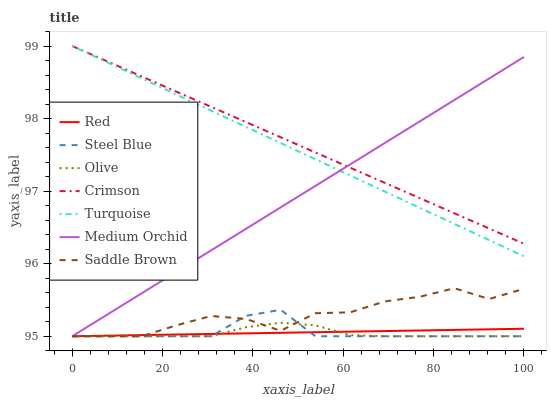Does Olive have the minimum area under the curve?
Answer yes or no. Yes. Does Crimson have the maximum area under the curve?
Answer yes or no. Yes. Does Medium Orchid have the minimum area under the curve?
Answer yes or no. No. Does Medium Orchid have the maximum area under the curve?
Answer yes or no. No. Is Crimson the smoothest?
Answer yes or no. Yes. Is Saddle Brown the roughest?
Answer yes or no. Yes. Is Medium Orchid the smoothest?
Answer yes or no. No. Is Medium Orchid the roughest?
Answer yes or no. No. Does Medium Orchid have the lowest value?
Answer yes or no. Yes. Does Crimson have the lowest value?
Answer yes or no. No. Does Crimson have the highest value?
Answer yes or no. Yes. Does Medium Orchid have the highest value?
Answer yes or no. No. Is Steel Blue less than Turquoise?
Answer yes or no. Yes. Is Crimson greater than Red?
Answer yes or no. Yes. Does Saddle Brown intersect Steel Blue?
Answer yes or no. Yes. Is Saddle Brown less than Steel Blue?
Answer yes or no. No. Is Saddle Brown greater than Steel Blue?
Answer yes or no. No. Does Steel Blue intersect Turquoise?
Answer yes or no. No. 